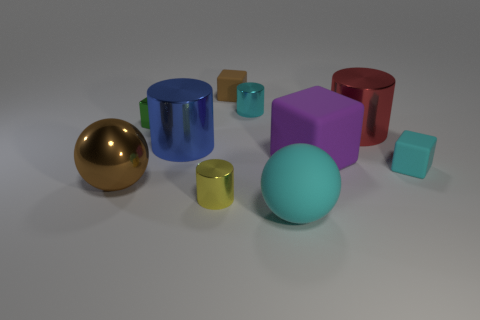How many gray things are small cylinders or spheres?
Keep it short and to the point. 0. What number of blue metal objects have the same size as the cyan ball?
Your answer should be compact. 1. Is the brown thing that is in front of the green shiny block made of the same material as the tiny green cube?
Your answer should be compact. Yes. Are there any small rubber objects that are on the left side of the shiny cylinder that is behind the green object?
Keep it short and to the point. Yes. There is another large object that is the same shape as the green object; what is its material?
Your response must be concise. Rubber. Are there more tiny blocks in front of the big purple thing than big matte balls left of the big blue shiny thing?
Your response must be concise. Yes. There is a big purple object that is the same material as the big cyan object; what shape is it?
Your response must be concise. Cube. Are there more cyan objects behind the cyan matte block than small brown shiny cubes?
Your response must be concise. Yes. What number of large metallic things have the same color as the large cube?
Ensure brevity in your answer.  0. How many other things are the same color as the large matte sphere?
Your answer should be very brief. 2. 